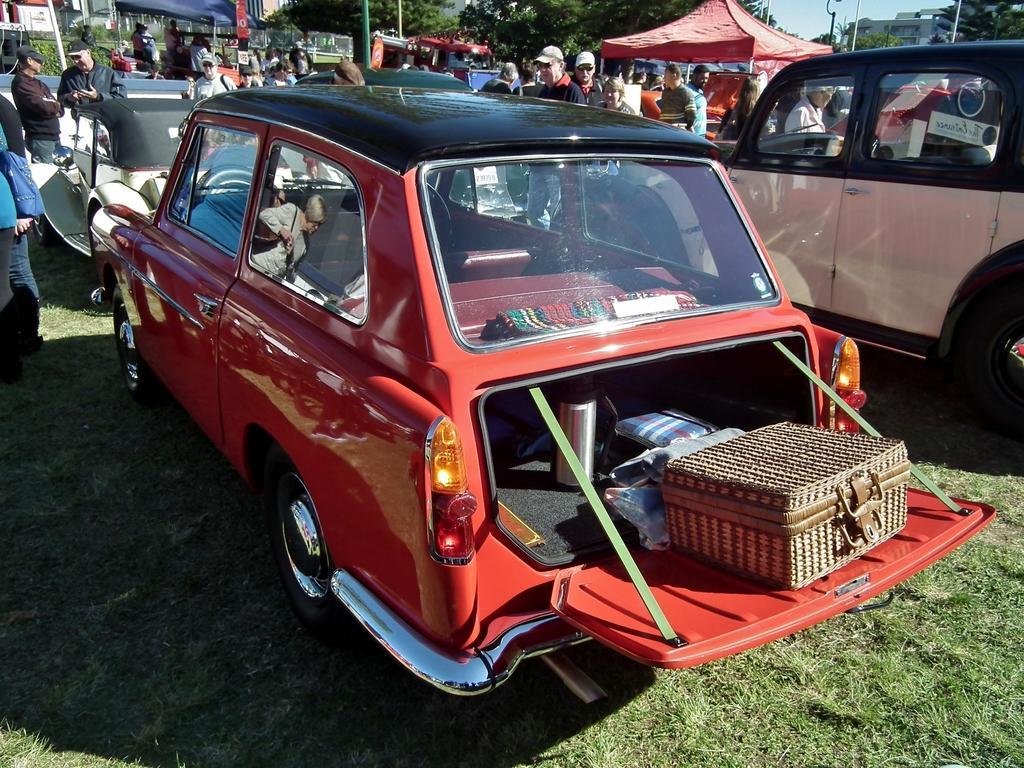In one or two sentences, can you explain what this image depicts? In this image we can see a red color car, back of the car some luggage is there. Behind the car so many people are standing. Right side of the image one more car is there, behind that car one tent is there and trees are present. 